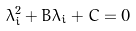Convert formula to latex. <formula><loc_0><loc_0><loc_500><loc_500>\lambda _ { i } ^ { 2 } + B \lambda _ { i } + C = 0</formula> 